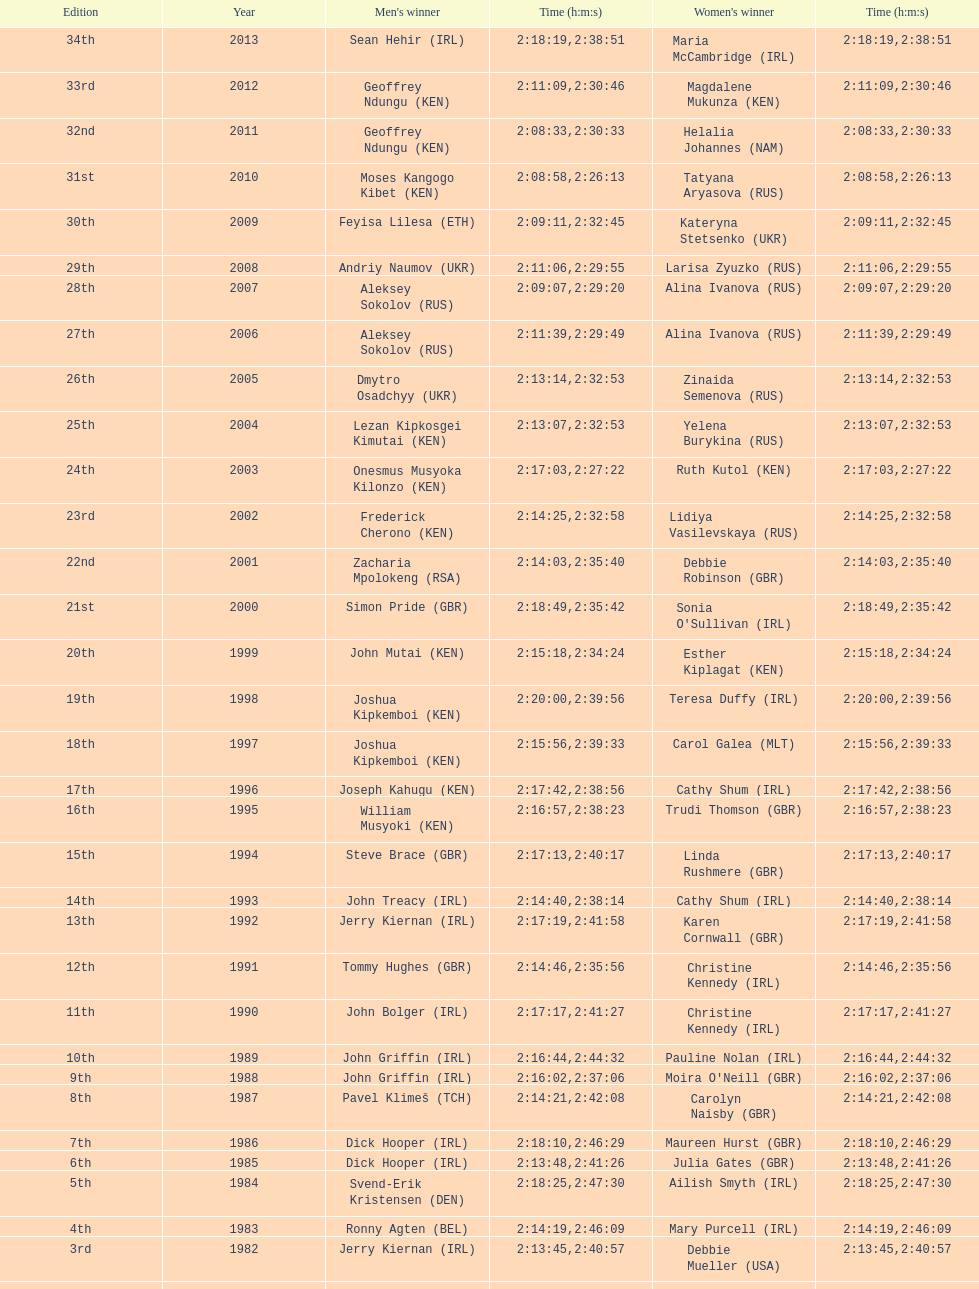Could you parse the entire table as a dict? {'header': ['Edition', 'Year', "Men's winner", 'Time (h:m:s)', "Women's winner", 'Time (h:m:s)'], 'rows': [['34th', '2013', 'Sean Hehir\xa0(IRL)', '2:18:19', 'Maria McCambridge\xa0(IRL)', '2:38:51'], ['33rd', '2012', 'Geoffrey Ndungu\xa0(KEN)', '2:11:09', 'Magdalene Mukunza\xa0(KEN)', '2:30:46'], ['32nd', '2011', 'Geoffrey Ndungu\xa0(KEN)', '2:08:33', 'Helalia Johannes\xa0(NAM)', '2:30:33'], ['31st', '2010', 'Moses Kangogo Kibet\xa0(KEN)', '2:08:58', 'Tatyana Aryasova\xa0(RUS)', '2:26:13'], ['30th', '2009', 'Feyisa Lilesa\xa0(ETH)', '2:09:11', 'Kateryna Stetsenko\xa0(UKR)', '2:32:45'], ['29th', '2008', 'Andriy Naumov\xa0(UKR)', '2:11:06', 'Larisa Zyuzko\xa0(RUS)', '2:29:55'], ['28th', '2007', 'Aleksey Sokolov\xa0(RUS)', '2:09:07', 'Alina Ivanova\xa0(RUS)', '2:29:20'], ['27th', '2006', 'Aleksey Sokolov\xa0(RUS)', '2:11:39', 'Alina Ivanova\xa0(RUS)', '2:29:49'], ['26th', '2005', 'Dmytro Osadchyy\xa0(UKR)', '2:13:14', 'Zinaida Semenova\xa0(RUS)', '2:32:53'], ['25th', '2004', 'Lezan Kipkosgei Kimutai\xa0(KEN)', '2:13:07', 'Yelena Burykina\xa0(RUS)', '2:32:53'], ['24th', '2003', 'Onesmus Musyoka Kilonzo\xa0(KEN)', '2:17:03', 'Ruth Kutol\xa0(KEN)', '2:27:22'], ['23rd', '2002', 'Frederick Cherono\xa0(KEN)', '2:14:25', 'Lidiya Vasilevskaya\xa0(RUS)', '2:32:58'], ['22nd', '2001', 'Zacharia Mpolokeng\xa0(RSA)', '2:14:03', 'Debbie Robinson\xa0(GBR)', '2:35:40'], ['21st', '2000', 'Simon Pride\xa0(GBR)', '2:18:49', "Sonia O'Sullivan\xa0(IRL)", '2:35:42'], ['20th', '1999', 'John Mutai\xa0(KEN)', '2:15:18', 'Esther Kiplagat\xa0(KEN)', '2:34:24'], ['19th', '1998', 'Joshua Kipkemboi\xa0(KEN)', '2:20:00', 'Teresa Duffy\xa0(IRL)', '2:39:56'], ['18th', '1997', 'Joshua Kipkemboi\xa0(KEN)', '2:15:56', 'Carol Galea\xa0(MLT)', '2:39:33'], ['17th', '1996', 'Joseph Kahugu\xa0(KEN)', '2:17:42', 'Cathy Shum\xa0(IRL)', '2:38:56'], ['16th', '1995', 'William Musyoki\xa0(KEN)', '2:16:57', 'Trudi Thomson\xa0(GBR)', '2:38:23'], ['15th', '1994', 'Steve Brace\xa0(GBR)', '2:17:13', 'Linda Rushmere\xa0(GBR)', '2:40:17'], ['14th', '1993', 'John Treacy\xa0(IRL)', '2:14:40', 'Cathy Shum\xa0(IRL)', '2:38:14'], ['13th', '1992', 'Jerry Kiernan\xa0(IRL)', '2:17:19', 'Karen Cornwall\xa0(GBR)', '2:41:58'], ['12th', '1991', 'Tommy Hughes\xa0(GBR)', '2:14:46', 'Christine Kennedy\xa0(IRL)', '2:35:56'], ['11th', '1990', 'John Bolger\xa0(IRL)', '2:17:17', 'Christine Kennedy\xa0(IRL)', '2:41:27'], ['10th', '1989', 'John Griffin\xa0(IRL)', '2:16:44', 'Pauline Nolan\xa0(IRL)', '2:44:32'], ['9th', '1988', 'John Griffin\xa0(IRL)', '2:16:02', "Moira O'Neill\xa0(GBR)", '2:37:06'], ['8th', '1987', 'Pavel Klimeš\xa0(TCH)', '2:14:21', 'Carolyn Naisby\xa0(GBR)', '2:42:08'], ['7th', '1986', 'Dick Hooper\xa0(IRL)', '2:18:10', 'Maureen Hurst\xa0(GBR)', '2:46:29'], ['6th', '1985', 'Dick Hooper\xa0(IRL)', '2:13:48', 'Julia Gates\xa0(GBR)', '2:41:26'], ['5th', '1984', 'Svend-Erik Kristensen\xa0(DEN)', '2:18:25', 'Ailish Smyth\xa0(IRL)', '2:47:30'], ['4th', '1983', 'Ronny Agten\xa0(BEL)', '2:14:19', 'Mary Purcell\xa0(IRL)', '2:46:09'], ['3rd', '1982', 'Jerry Kiernan\xa0(IRL)', '2:13:45', 'Debbie Mueller\xa0(USA)', '2:40:57'], ['2nd', '1981', 'Neil Cusack\xa0(IRL)', '2:13:58', 'Emily Dowling\xa0(IRL)', '2:48:22'], ['1st', '1980', 'Dick Hooper\xa0(IRL)', '2:16:14', 'Carey May\xa0(IRL)', '2:42:11']]} Which country has both its male and female citizens at the top of the rankings? Ireland. 